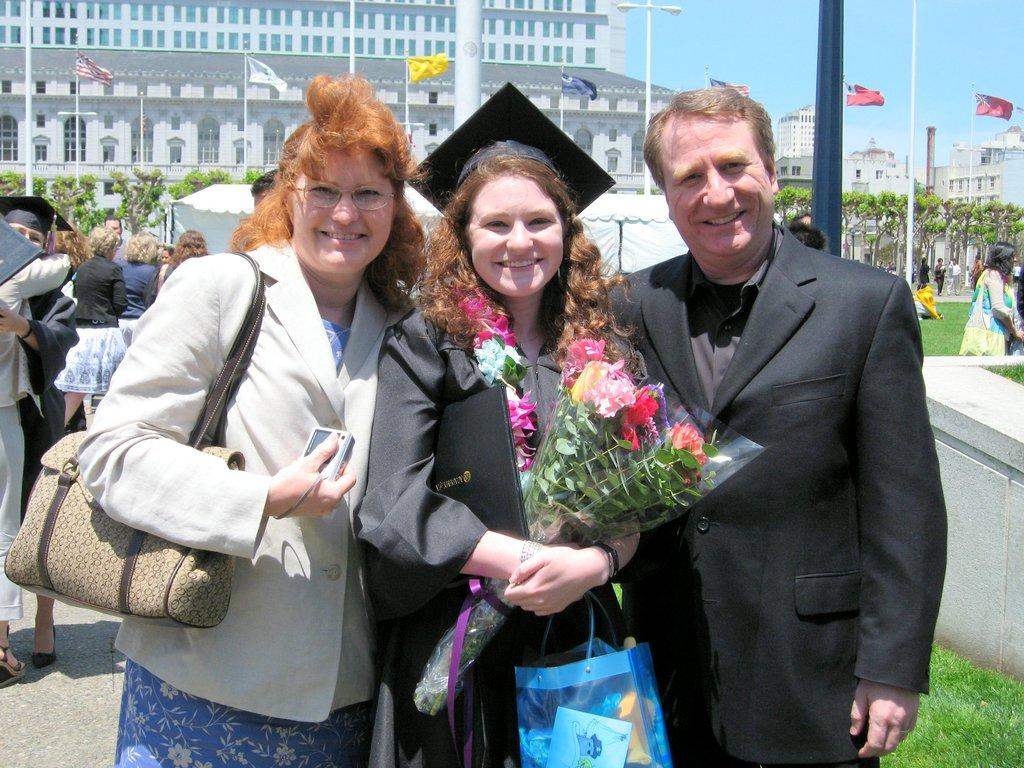How many people are in the image? There are three people in the image. What are the people doing in the image? The people are standing and smiling. What can be seen in the background of the image? There is a building, flags, and trees in the background of the image. What type of pencil can be seen in the image? There is no pencil present in the image. Is there a jail visible in the image? There is no jail present in the image. 